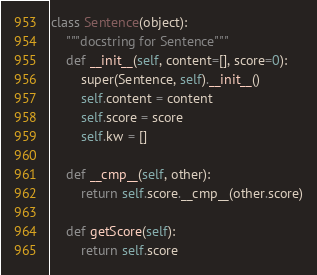Convert code to text. <code><loc_0><loc_0><loc_500><loc_500><_Python_>class Sentence(object):
	"""docstring for Sentence"""
	def __init__(self, content=[], score=0):
		super(Sentence, self).__init__()
		self.content = content
		self.score = score
		self.kw = []

	def __cmp__(self, other):
		return self.score.__cmp__(other.score)

	def getScore(self):
		return self.score
</code> 